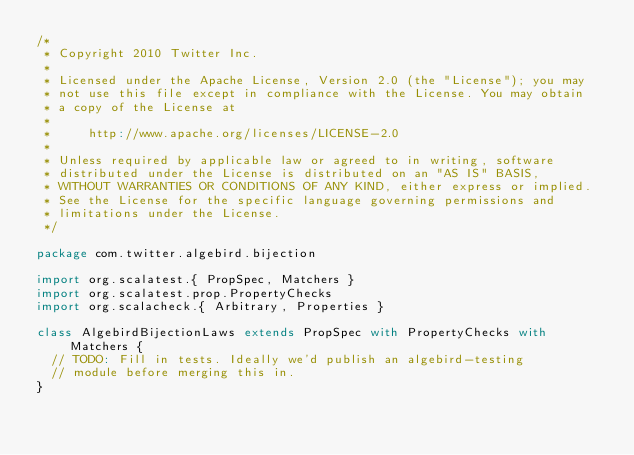<code> <loc_0><loc_0><loc_500><loc_500><_Scala_>/*
 * Copyright 2010 Twitter Inc.
 *
 * Licensed under the Apache License, Version 2.0 (the "License"); you may
 * not use this file except in compliance with the License. You may obtain
 * a copy of the License at
 *
 *     http://www.apache.org/licenses/LICENSE-2.0
 *
 * Unless required by applicable law or agreed to in writing, software
 * distributed under the License is distributed on an "AS IS" BASIS,
 * WITHOUT WARRANTIES OR CONDITIONS OF ANY KIND, either express or implied.
 * See the License for the specific language governing permissions and
 * limitations under the License.
 */

package com.twitter.algebird.bijection

import org.scalatest.{ PropSpec, Matchers }
import org.scalatest.prop.PropertyChecks
import org.scalacheck.{ Arbitrary, Properties }

class AlgebirdBijectionLaws extends PropSpec with PropertyChecks with Matchers {
  // TODO: Fill in tests. Ideally we'd publish an algebird-testing
  // module before merging this in.
}
</code> 